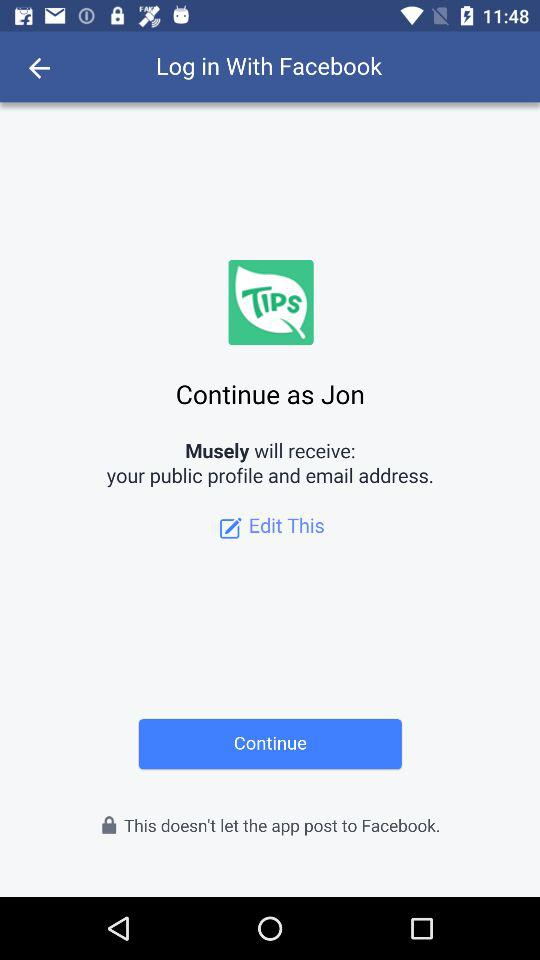What is the name of the user? The name of the user is Jon. 